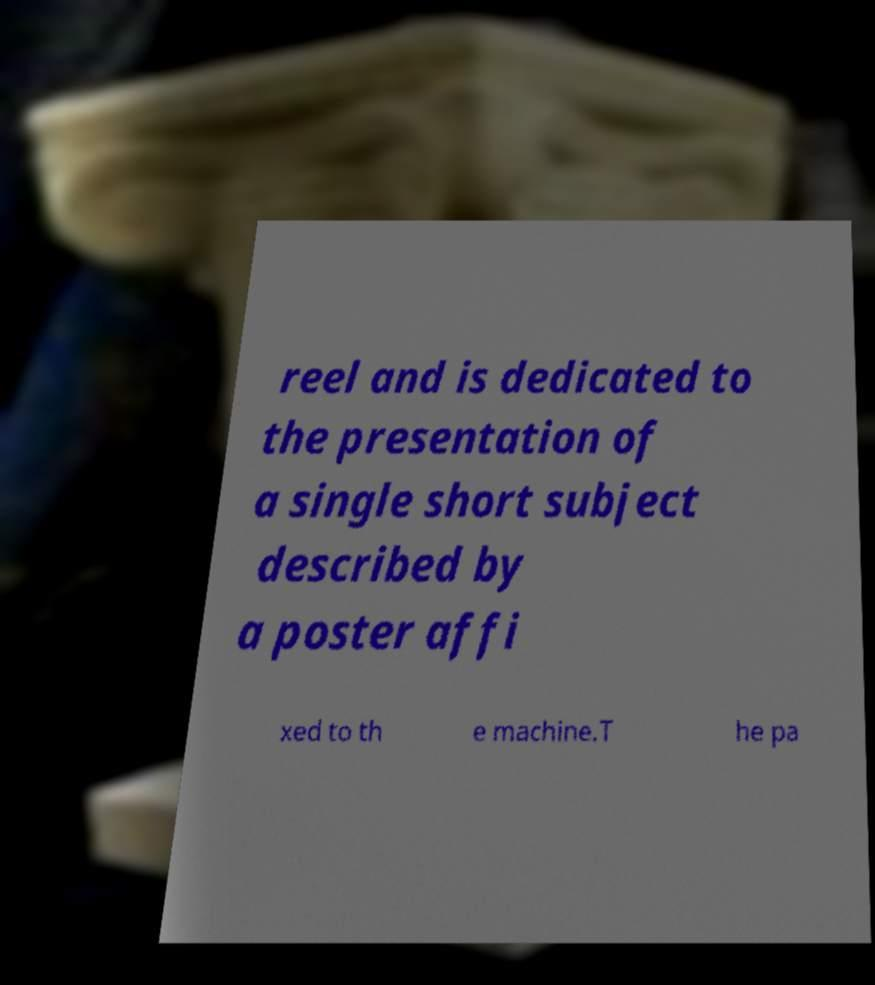Could you assist in decoding the text presented in this image and type it out clearly? reel and is dedicated to the presentation of a single short subject described by a poster affi xed to th e machine.T he pa 